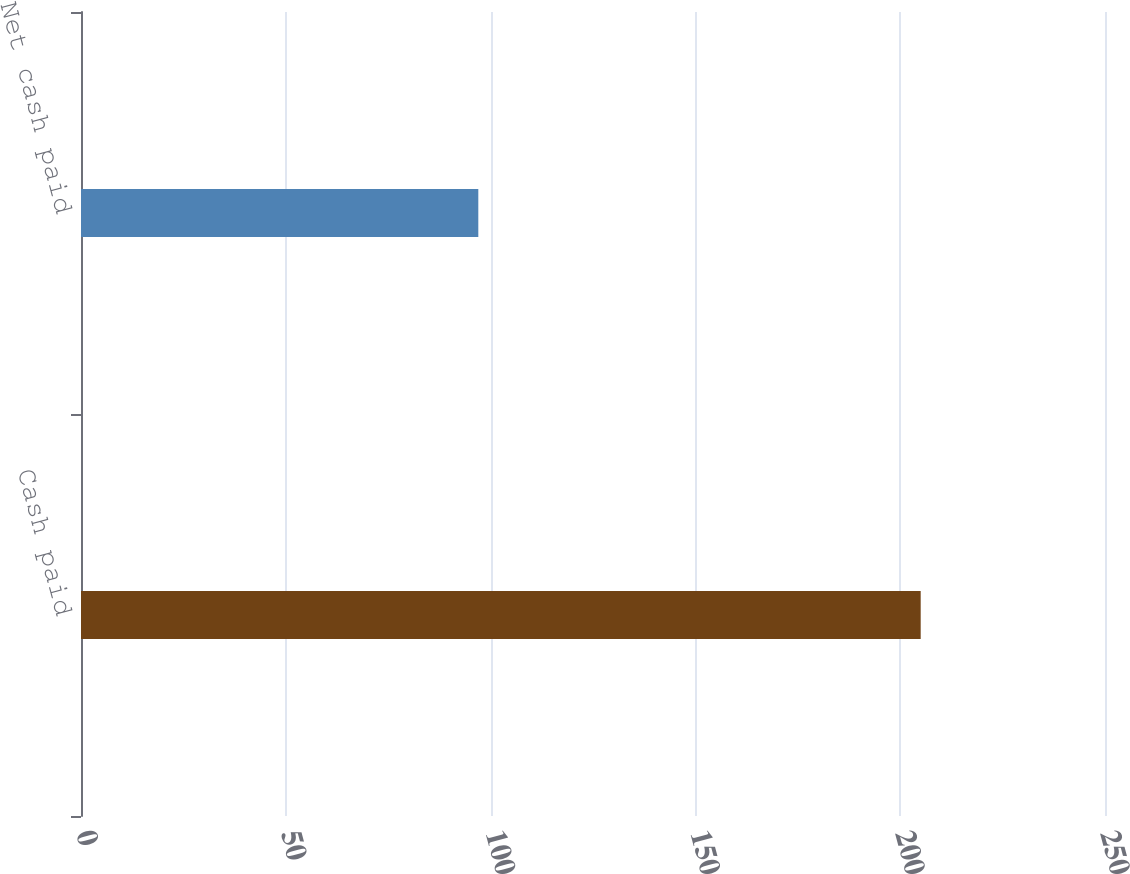Convert chart. <chart><loc_0><loc_0><loc_500><loc_500><bar_chart><fcel>Cash paid<fcel>Net cash paid<nl><fcel>205<fcel>97<nl></chart> 